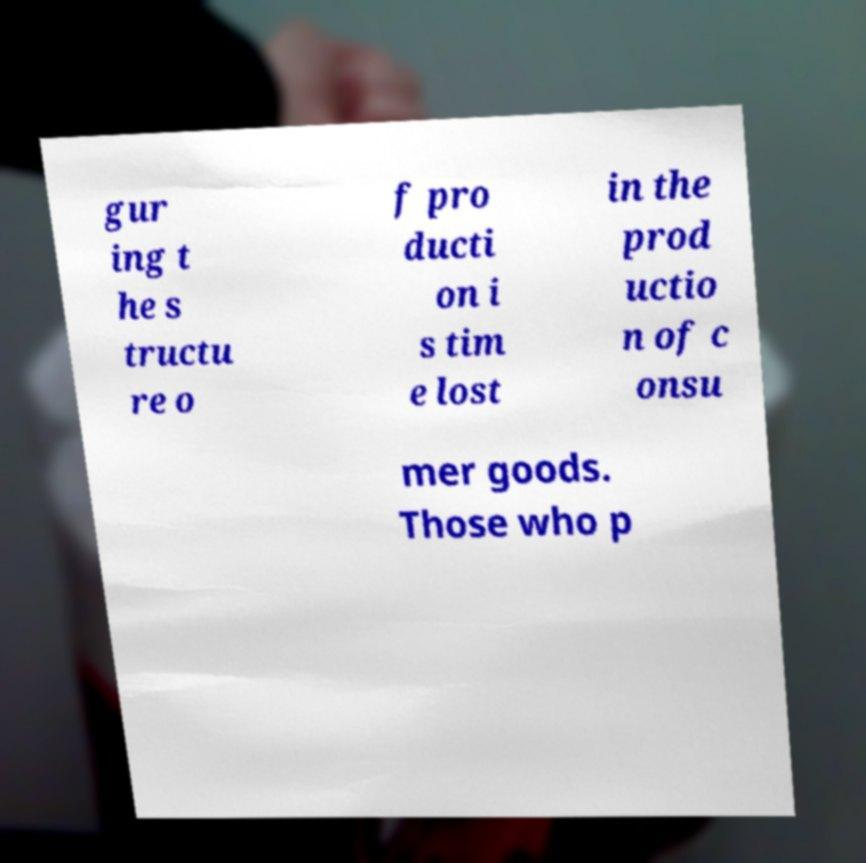I need the written content from this picture converted into text. Can you do that? gur ing t he s tructu re o f pro ducti on i s tim e lost in the prod uctio n of c onsu mer goods. Those who p 